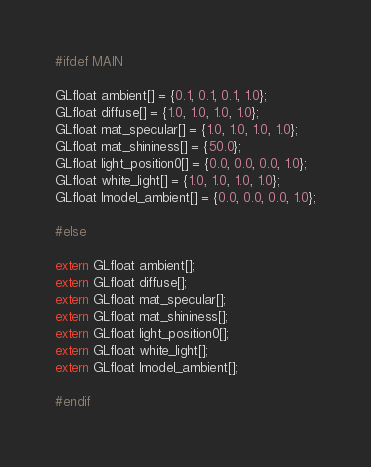Convert code to text. <code><loc_0><loc_0><loc_500><loc_500><_C_>#ifdef MAIN

GLfloat ambient[] = {0.1, 0.1, 0.1, 1.0};
GLfloat diffuse[] = {1.0, 1.0, 1.0, 1.0};
GLfloat mat_specular[] = {1.0, 1.0, 1.0, 1.0};
GLfloat mat_shininess[] = {50.0};
GLfloat light_position0[] = {0.0, 0.0, 0.0, 1.0};
GLfloat white_light[] = {1.0, 1.0, 1.0, 1.0};
GLfloat lmodel_ambient[] = {0.0, 0.0, 0.0, 1.0};

#else

extern GLfloat ambient[];
extern GLfloat diffuse[];
extern GLfloat mat_specular[];
extern GLfloat mat_shininess[];
extern GLfloat light_position0[];
extern GLfloat white_light[];
extern GLfloat lmodel_ambient[];

#endif</code> 